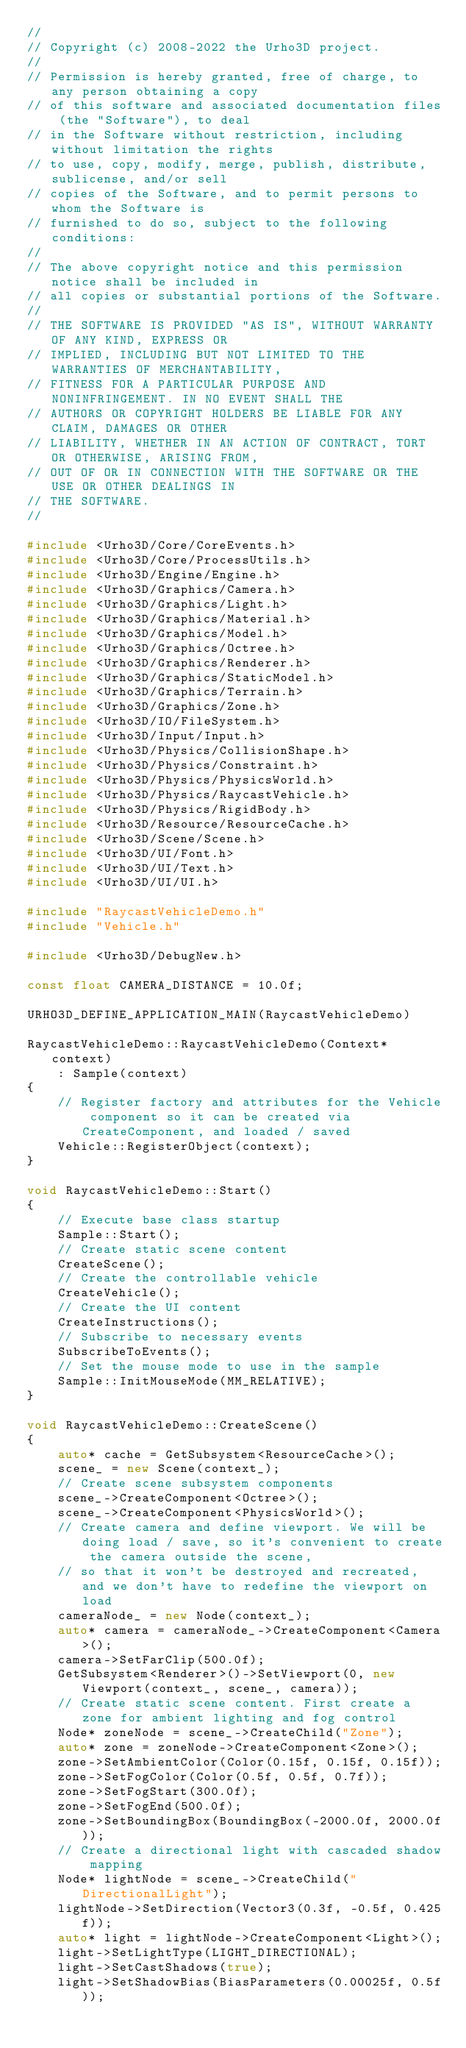<code> <loc_0><loc_0><loc_500><loc_500><_C++_>//
// Copyright (c) 2008-2022 the Urho3D project.
//
// Permission is hereby granted, free of charge, to any person obtaining a copy
// of this software and associated documentation files (the "Software"), to deal
// in the Software without restriction, including without limitation the rights
// to use, copy, modify, merge, publish, distribute, sublicense, and/or sell
// copies of the Software, and to permit persons to whom the Software is
// furnished to do so, subject to the following conditions:
//
// The above copyright notice and this permission notice shall be included in
// all copies or substantial portions of the Software.
//
// THE SOFTWARE IS PROVIDED "AS IS", WITHOUT WARRANTY OF ANY KIND, EXPRESS OR
// IMPLIED, INCLUDING BUT NOT LIMITED TO THE WARRANTIES OF MERCHANTABILITY,
// FITNESS FOR A PARTICULAR PURPOSE AND NONINFRINGEMENT. IN NO EVENT SHALL THE
// AUTHORS OR COPYRIGHT HOLDERS BE LIABLE FOR ANY CLAIM, DAMAGES OR OTHER
// LIABILITY, WHETHER IN AN ACTION OF CONTRACT, TORT OR OTHERWISE, ARISING FROM,
// OUT OF OR IN CONNECTION WITH THE SOFTWARE OR THE USE OR OTHER DEALINGS IN
// THE SOFTWARE.
//

#include <Urho3D/Core/CoreEvents.h>
#include <Urho3D/Core/ProcessUtils.h>
#include <Urho3D/Engine/Engine.h>
#include <Urho3D/Graphics/Camera.h>
#include <Urho3D/Graphics/Light.h>
#include <Urho3D/Graphics/Material.h>
#include <Urho3D/Graphics/Model.h>
#include <Urho3D/Graphics/Octree.h>
#include <Urho3D/Graphics/Renderer.h>
#include <Urho3D/Graphics/StaticModel.h>
#include <Urho3D/Graphics/Terrain.h>
#include <Urho3D/Graphics/Zone.h>
#include <Urho3D/IO/FileSystem.h>
#include <Urho3D/Input/Input.h>
#include <Urho3D/Physics/CollisionShape.h>
#include <Urho3D/Physics/Constraint.h>
#include <Urho3D/Physics/PhysicsWorld.h>
#include <Urho3D/Physics/RaycastVehicle.h>
#include <Urho3D/Physics/RigidBody.h>
#include <Urho3D/Resource/ResourceCache.h>
#include <Urho3D/Scene/Scene.h>
#include <Urho3D/UI/Font.h>
#include <Urho3D/UI/Text.h>
#include <Urho3D/UI/UI.h>

#include "RaycastVehicleDemo.h"
#include "Vehicle.h"

#include <Urho3D/DebugNew.h>

const float CAMERA_DISTANCE = 10.0f;

URHO3D_DEFINE_APPLICATION_MAIN(RaycastVehicleDemo)

RaycastVehicleDemo::RaycastVehicleDemo(Context* context)
    : Sample(context)
{
    // Register factory and attributes for the Vehicle component so it can be created via CreateComponent, and loaded / saved
    Vehicle::RegisterObject(context);
}

void RaycastVehicleDemo::Start()
{
    // Execute base class startup
    Sample::Start();
    // Create static scene content
    CreateScene();
    // Create the controllable vehicle
    CreateVehicle();
    // Create the UI content
    CreateInstructions();
    // Subscribe to necessary events
    SubscribeToEvents();
    // Set the mouse mode to use in the sample
    Sample::InitMouseMode(MM_RELATIVE);
}

void RaycastVehicleDemo::CreateScene()
{
    auto* cache = GetSubsystem<ResourceCache>();
    scene_ = new Scene(context_);
    // Create scene subsystem components
    scene_->CreateComponent<Octree>();
    scene_->CreateComponent<PhysicsWorld>();
    // Create camera and define viewport. We will be doing load / save, so it's convenient to create the camera outside the scene,
    // so that it won't be destroyed and recreated, and we don't have to redefine the viewport on load
    cameraNode_ = new Node(context_);
    auto* camera = cameraNode_->CreateComponent<Camera>();
    camera->SetFarClip(500.0f);
    GetSubsystem<Renderer>()->SetViewport(0, new Viewport(context_, scene_, camera));
    // Create static scene content. First create a zone for ambient lighting and fog control
    Node* zoneNode = scene_->CreateChild("Zone");
    auto* zone = zoneNode->CreateComponent<Zone>();
    zone->SetAmbientColor(Color(0.15f, 0.15f, 0.15f));
    zone->SetFogColor(Color(0.5f, 0.5f, 0.7f));
    zone->SetFogStart(300.0f);
    zone->SetFogEnd(500.0f);
    zone->SetBoundingBox(BoundingBox(-2000.0f, 2000.0f));
    // Create a directional light with cascaded shadow mapping
    Node* lightNode = scene_->CreateChild("DirectionalLight");
    lightNode->SetDirection(Vector3(0.3f, -0.5f, 0.425f));
    auto* light = lightNode->CreateComponent<Light>();
    light->SetLightType(LIGHT_DIRECTIONAL);
    light->SetCastShadows(true);
    light->SetShadowBias(BiasParameters(0.00025f, 0.5f));</code> 